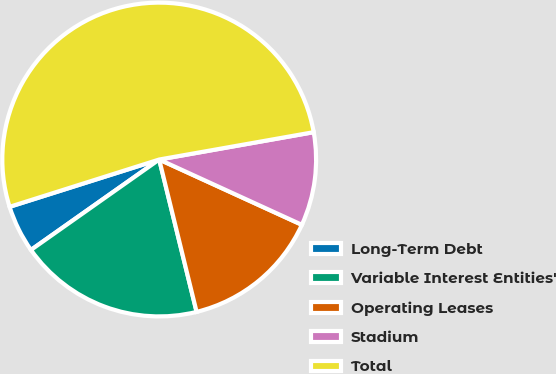<chart> <loc_0><loc_0><loc_500><loc_500><pie_chart><fcel>Long-Term Debt<fcel>Variable Interest Entities'<fcel>Operating Leases<fcel>Stadium<fcel>Total<nl><fcel>4.9%<fcel>19.06%<fcel>14.34%<fcel>9.62%<fcel>52.09%<nl></chart> 